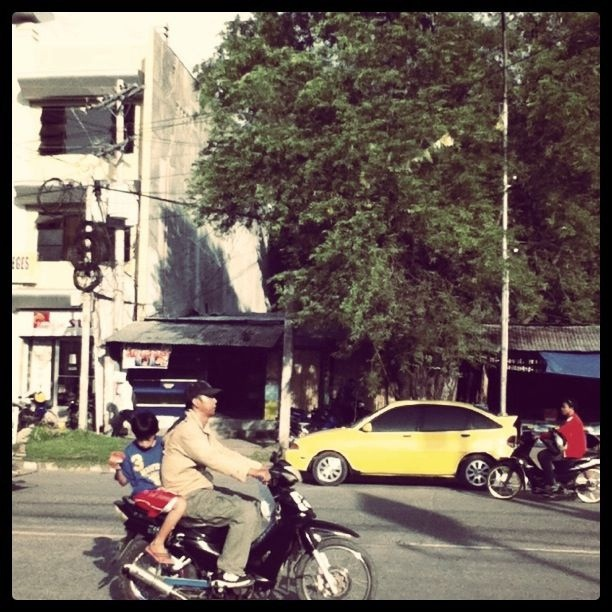Describe the objects in this image and their specific colors. I can see motorcycle in black, gray, and darkgray tones, car in black, khaki, and gray tones, people in black, tan, and beige tones, motorcycle in black, gray, and darkgray tones, and people in black, gray, and tan tones in this image. 